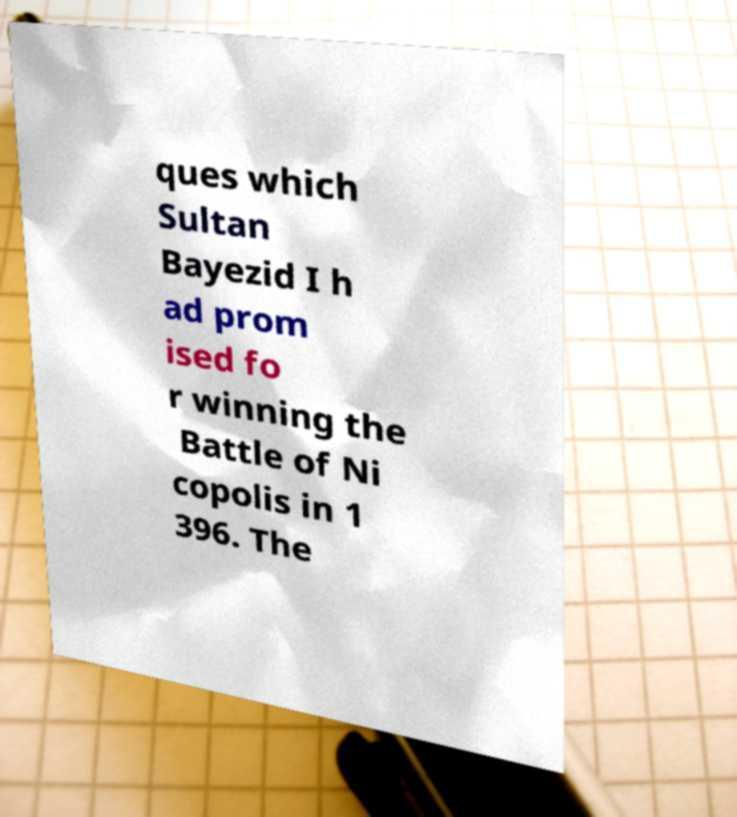Can you accurately transcribe the text from the provided image for me? ques which Sultan Bayezid I h ad prom ised fo r winning the Battle of Ni copolis in 1 396. The 